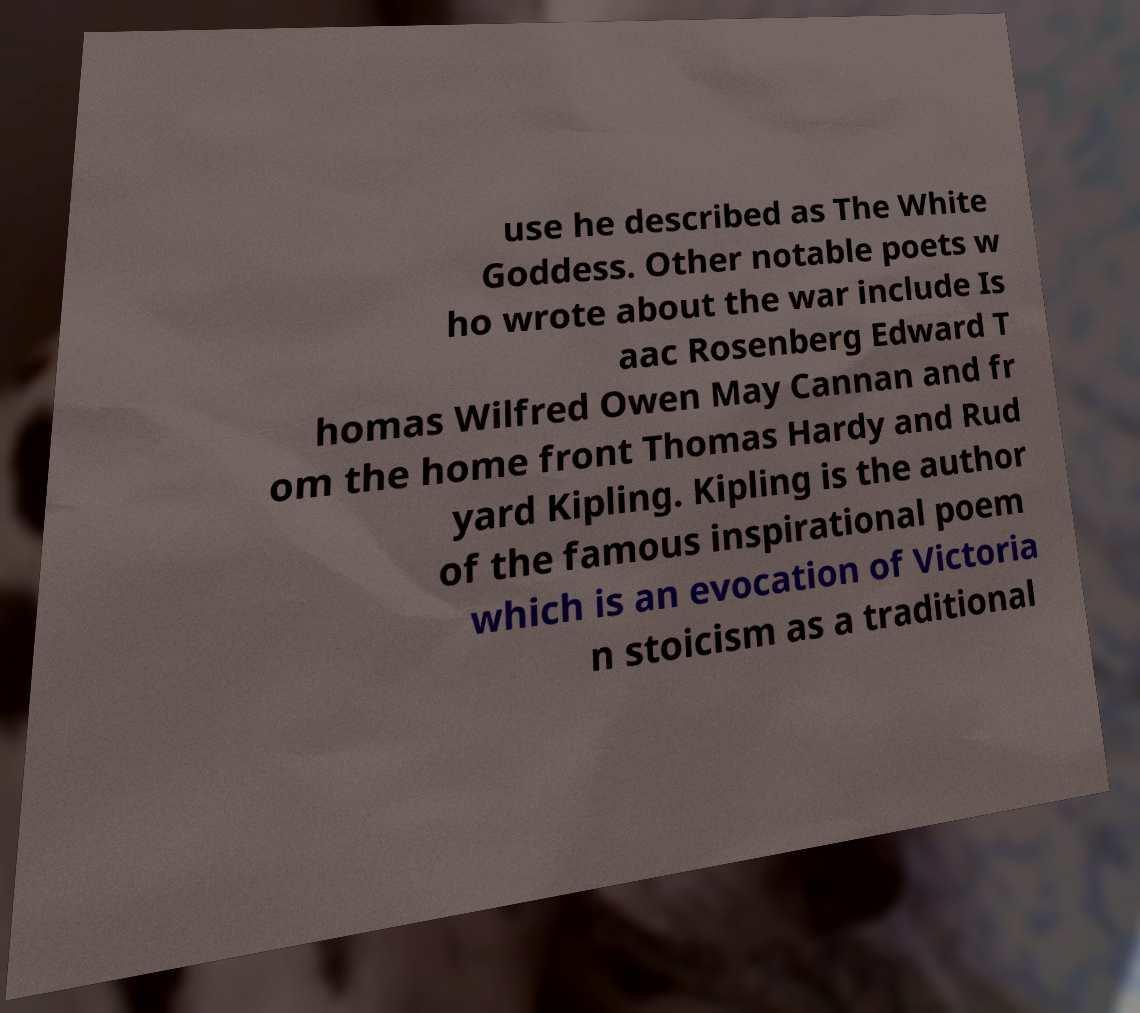For documentation purposes, I need the text within this image transcribed. Could you provide that? use he described as The White Goddess. Other notable poets w ho wrote about the war include Is aac Rosenberg Edward T homas Wilfred Owen May Cannan and fr om the home front Thomas Hardy and Rud yard Kipling. Kipling is the author of the famous inspirational poem which is an evocation of Victoria n stoicism as a traditional 